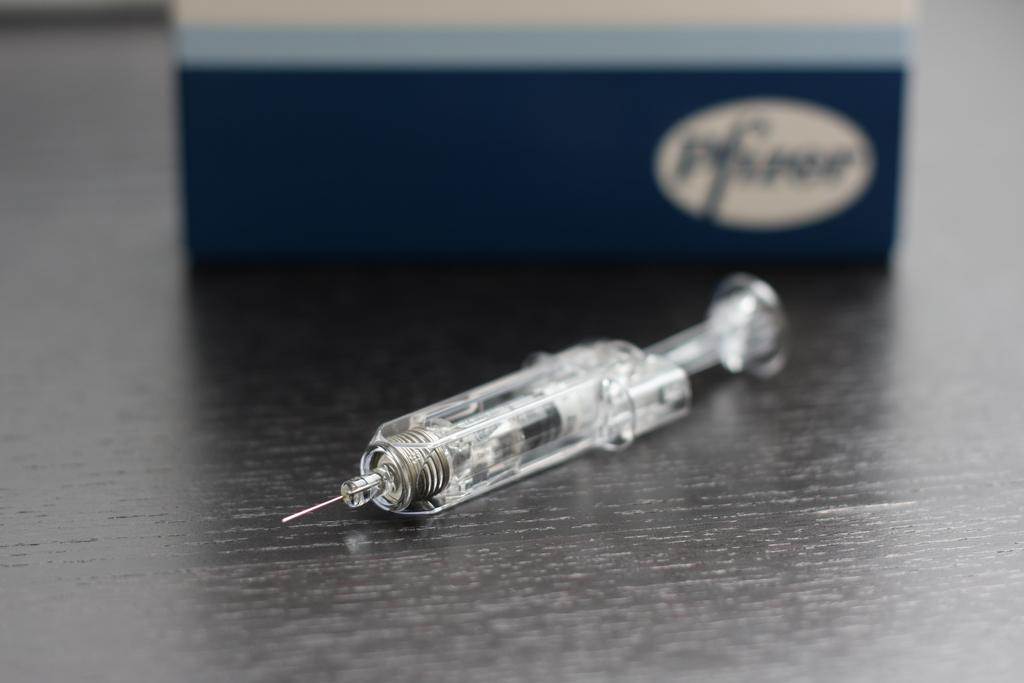What is the main object in the image? There is a wooden plank in the image. What is placed on the wooden plank? There is an injection on the wooden plank. What can be seen behind the wooden plank? There is a blue color box behind the wooden plank. What type of authority figure can be seen in the image? There is no authority figure present in the image. What type of office furniture is visible in the image? There is no office furniture present in the image. 